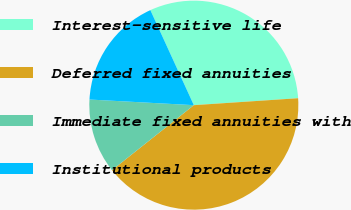Convert chart to OTSL. <chart><loc_0><loc_0><loc_500><loc_500><pie_chart><fcel>Interest-sensitive life<fcel>Deferred fixed annuities<fcel>Immediate fixed annuities with<fcel>Institutional products<nl><fcel>30.77%<fcel>40.38%<fcel>11.54%<fcel>17.31%<nl></chart> 